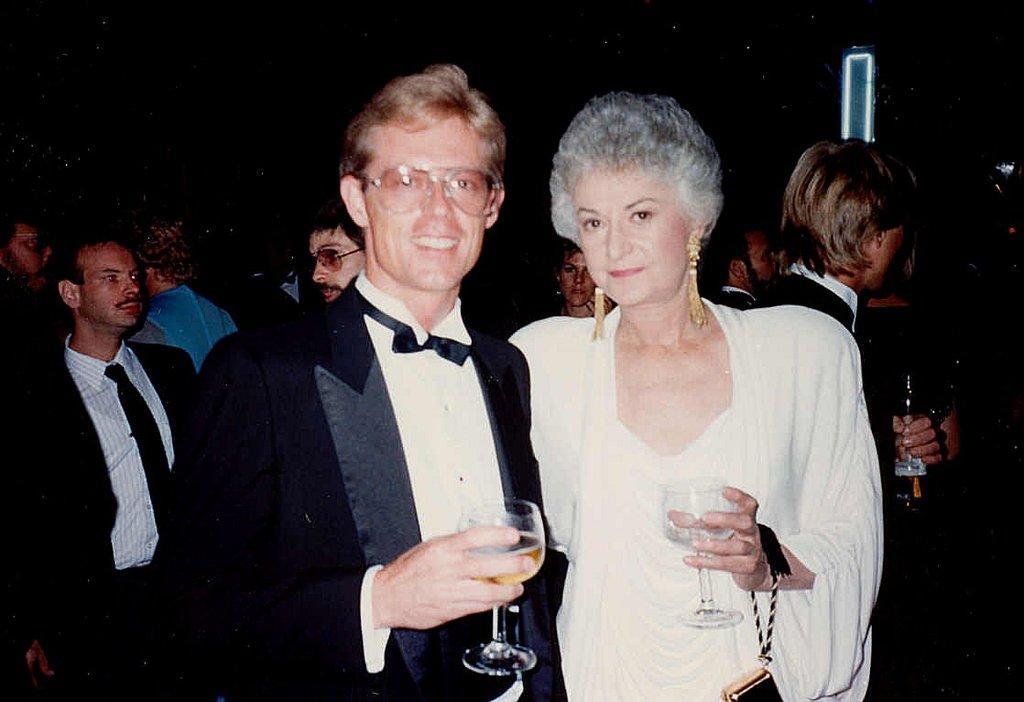Please provide a concise description of this image. This picture shows a group of people Standing and few people holding wine glasses in their hands 